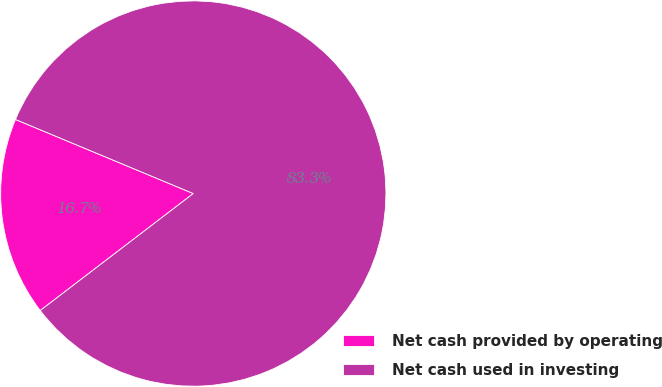<chart> <loc_0><loc_0><loc_500><loc_500><pie_chart><fcel>Net cash provided by operating<fcel>Net cash used in investing<nl><fcel>16.67%<fcel>83.33%<nl></chart> 